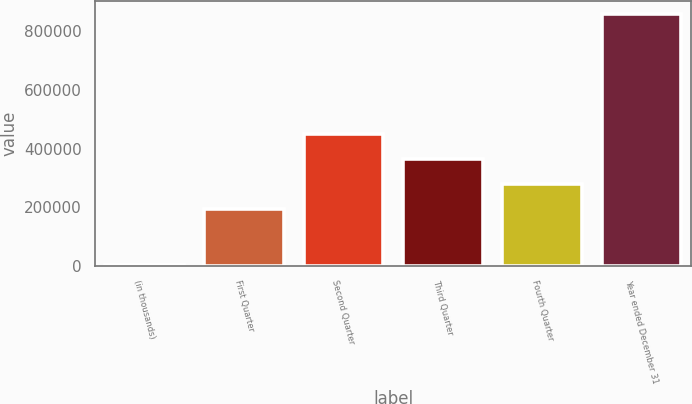Convert chart to OTSL. <chart><loc_0><loc_0><loc_500><loc_500><bar_chart><fcel>(in thousands)<fcel>First Quarter<fcel>Second Quarter<fcel>Third Quarter<fcel>Fourth Quarter<fcel>Year ended December 31<nl><fcel>2006<fcel>194187<fcel>451249<fcel>365561<fcel>279874<fcel>858878<nl></chart> 